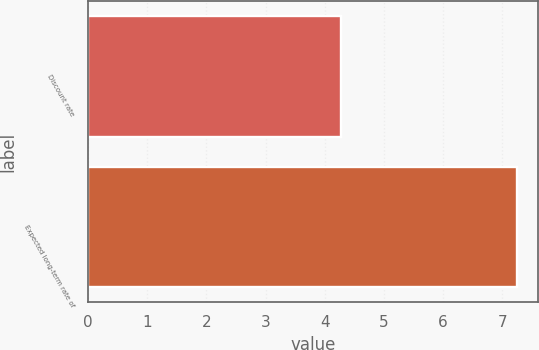Convert chart to OTSL. <chart><loc_0><loc_0><loc_500><loc_500><bar_chart><fcel>Discount rate<fcel>Expected long-term rate of<nl><fcel>4.27<fcel>7.25<nl></chart> 